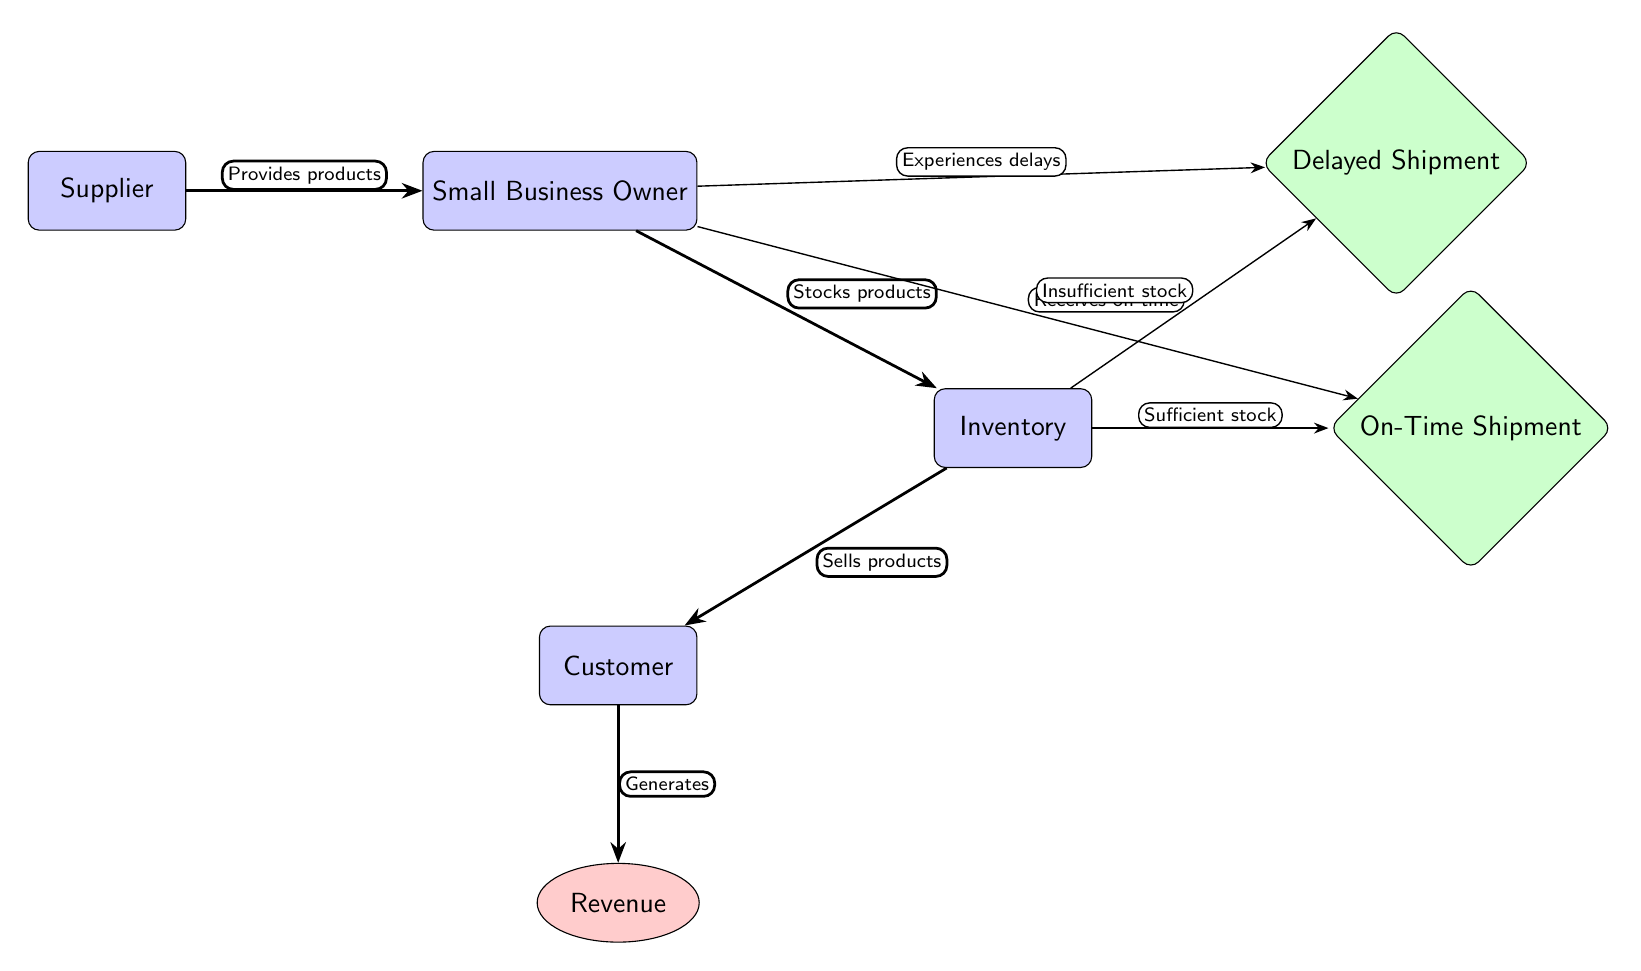What is the main role of the Supplier? The diagram shows that the Supplier "Provides products" to the Small Business Owner, indicating their primary role in the supply chain.
Answer: Provides products How many events are illustrated in the diagram? By counting the events depicted in the diagram, we can see that there are two: "Delayed Shipment" and "On-Time Shipment."
Answer: 2 What happens when Inventory has insufficient stock? According to the diagram, if Inventory has insufficient stock, the outcome leads to "Delayed Shipment" indicated by the arrow labeled "Insufficient stock."
Answer: Delayed Shipment What connects the Customer to Revenue in the diagram? The diagram highlights a direct relationship where the Customer "Generates" Revenue, showing their connection through the arrow.
Answer: Generates If the Small Business Owner receives products on time, what is the likely outcome? Referring to the diagram, receiving products on time indicates that Inventory has "Sufficient stock," which leads to a successful sales process without delay.
Answer: On-Time Shipment What does the flow from the Business Owner to Delayed Shipment indicate? The arrow from the Business Owner to "Delayed Shipment" illustrates that the Business Owner experiences delays, affecting their operations.
Answer: Experiences delays Which entity is responsible for stocking the products? The diagram clearly points out the Small Business Owner's role in this process with the label "Stocks products" connecting them to Inventory.
Answer: Small Business Owner What leads to the relationship between Inventory and On-Time Shipment? The diagram demonstrates that Inventory must have "Sufficient stock" to achieve "On-Time Shipment," highlighting the need for proper inventory levels.
Answer: Sufficient stock 